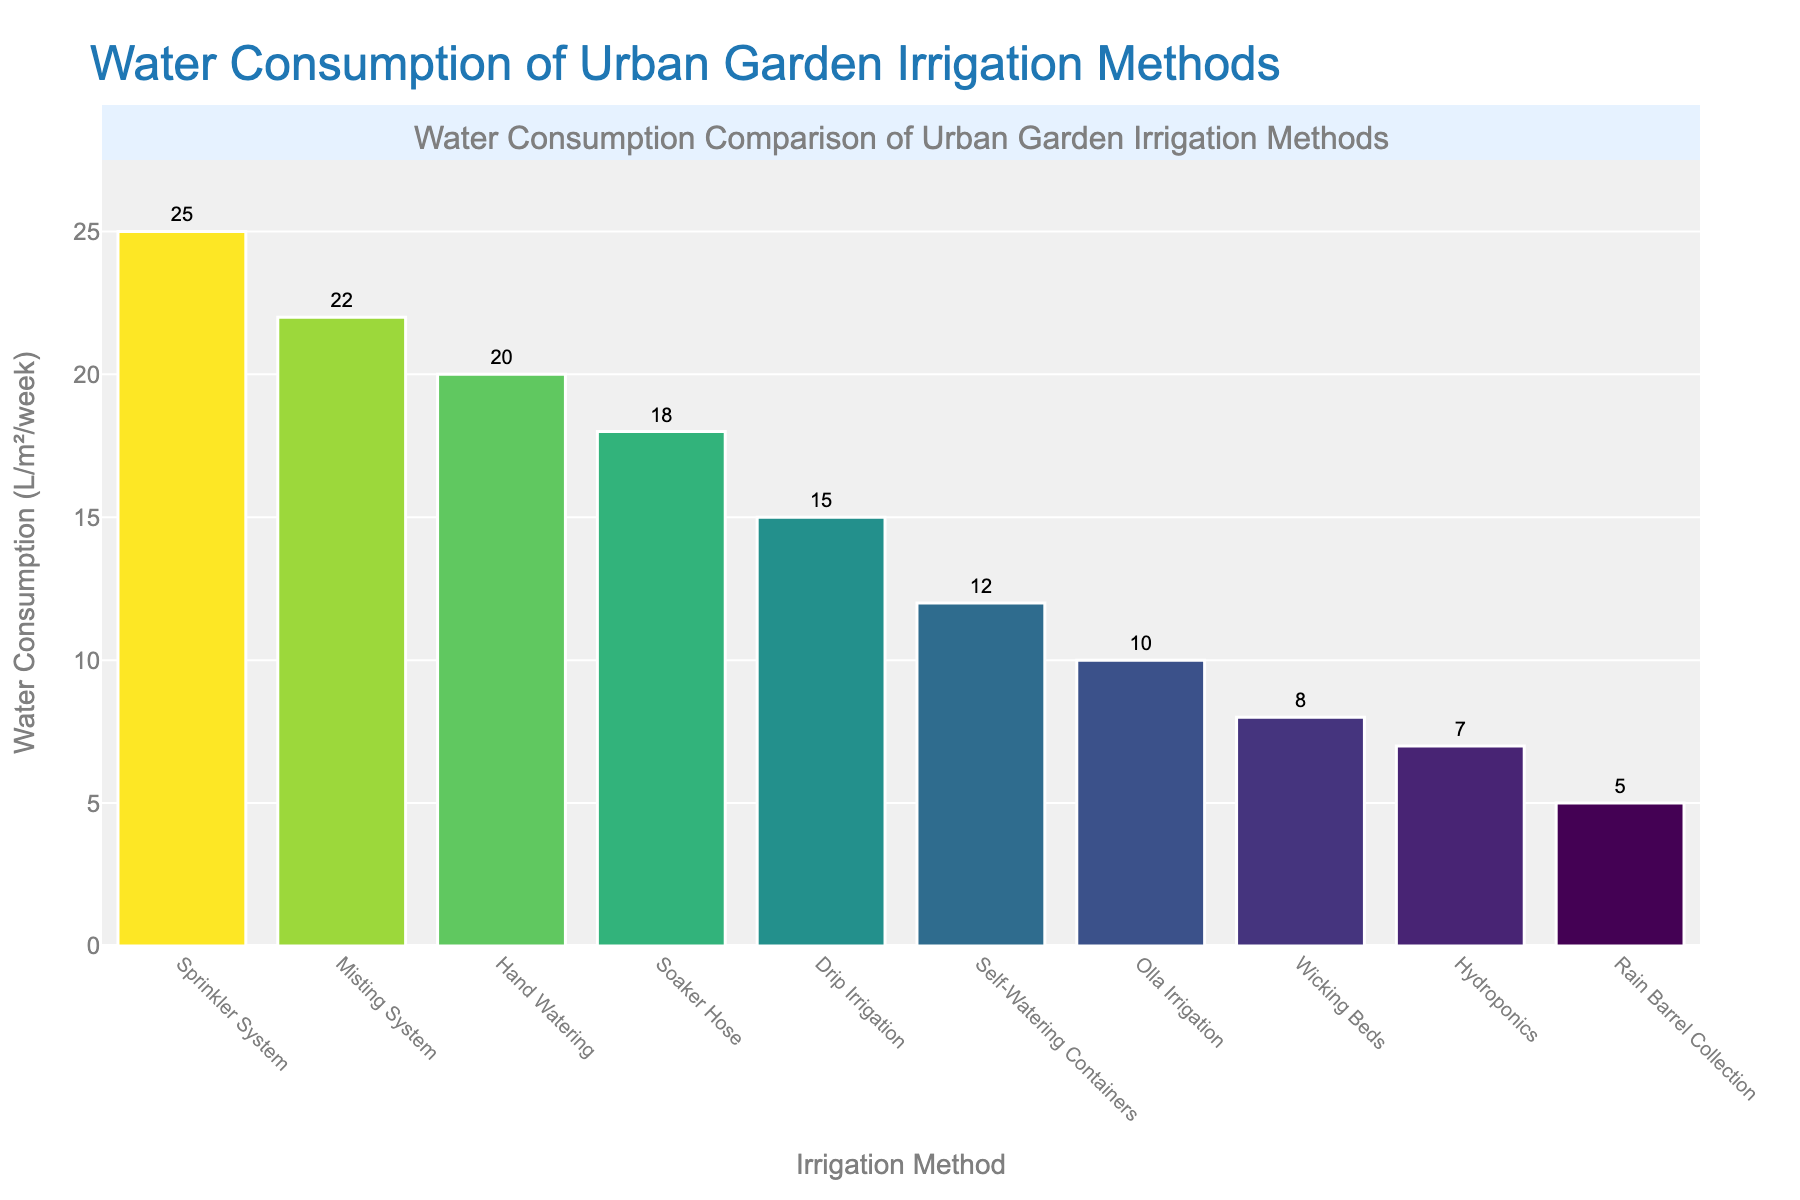Which irrigation method has the highest water consumption? The bar representing the sprinkler system is the tallest among the bars, indicating the highest water consumption.
Answer: Sprinkler System What is the difference in water consumption between hand watering and drip irrigation? Hand watering consumes 20 liters per square meter per week, and drip irrigation uses 15 liters per square meter per week. The difference is 20 - 15.
Answer: 5 liters per square meter per week Which irrigation method uses the least amount of water? The bar representing rain barrel collection is the shortest, indicating the lowest water consumption.
Answer: Rain Barrel Collection How many liters per square meter per week does the soaker hose method consume? Referring to the text label above the soaker hose bar, it shows 18 liters per square meter per week.
Answer: 18 liters per square meter per week Order the irrigation methods from lowest to highest water consumption. The bars' heights indicate their water consumption, from lowest to highest: Rain Barrel Collection (5), Hydroponics (7), Wicking Beds (8), Olla Irrigation (10), Self-Watering Containers (12), Drip Irrigation (15), Soaker Hose (18), Hand Watering (20), Misting System (22), Sprinkler System (25).
Answer: Rain Barrel Collection, Hydroponics, Wicking Beds, Olla Irrigation, Self-Watering Containers, Drip Irrigation, Soaker Hose, Hand Watering, Misting System, Sprinkler System How much more water does the self-watering container method save compared to hand watering? Hand watering consumes 20 liters per square meter per week, and self-watering containers consume 12 liters. The difference in water saved is 20 - 12 liters.
Answer: 8 liters per square meter per week What is the average water consumption of all listed irrigation methods? The sum of the water consumption values is 20+25+15+18+12+10+8+22+5+7 = 142 liters. There are 10 methods, so the average is 142 / 10.
Answer: 14.2 liters per square meter per week Compare the water consumption of the misting system with that of the wicking beds. Which one uses more water? The misting system bar shows 22 liters per square meter per week, while the wicking beds bar is shorter at 8 liters per square meter per week. Thus, the misting system uses more water.
Answer: Misting System If the objective is to use methods using less than 15 liters per square meter per week, which methods would you consider? Filtering methods with consumption under 15 liters are: Rain Barrel Collection (5), Hydroponics (7), Wicking Beds (8), Olla Irrigation (10), and Self-Watering Containers (12).
Answer: Rain Barrel Collection, Hydroponics, Wicking Beds, Olla Irrigation, Self-Watering Containers 